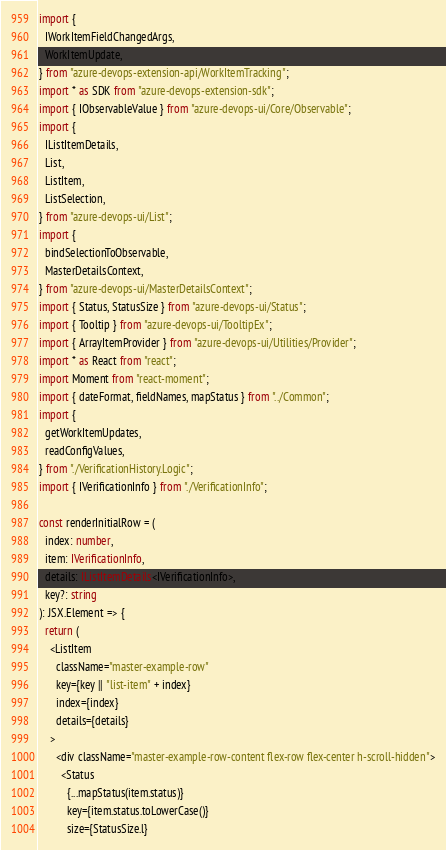Convert code to text. <code><loc_0><loc_0><loc_500><loc_500><_TypeScript_>import {
  IWorkItemFieldChangedArgs,
  WorkItemUpdate,
} from "azure-devops-extension-api/WorkItemTracking";
import * as SDK from "azure-devops-extension-sdk";
import { IObservableValue } from "azure-devops-ui/Core/Observable";
import {
  IListItemDetails,
  List,
  ListItem,
  ListSelection,
} from "azure-devops-ui/List";
import {
  bindSelectionToObservable,
  MasterDetailsContext,
} from "azure-devops-ui/MasterDetailsContext";
import { Status, StatusSize } from "azure-devops-ui/Status";
import { Tooltip } from "azure-devops-ui/TooltipEx";
import { ArrayItemProvider } from "azure-devops-ui/Utilities/Provider";
import * as React from "react";
import Moment from "react-moment";
import { dateFormat, fieldNames, mapStatus } from "../Common";
import {
  getWorkItemUpdates,
  readConfigValues,
} from "./VerificationHistory.Logic";
import { IVerificationInfo } from "./VerificationInfo";

const renderInitialRow = (
  index: number,
  item: IVerificationInfo,
  details: IListItemDetails<IVerificationInfo>,
  key?: string
): JSX.Element => {
  return (
    <ListItem
      className="master-example-row"
      key={key || "list-item" + index}
      index={index}
      details={details}
    >
      <div className="master-example-row-content flex-row flex-center h-scroll-hidden">
        <Status
          {...mapStatus(item.status)}
          key={item.status.toLowerCase()}
          size={StatusSize.l}</code> 